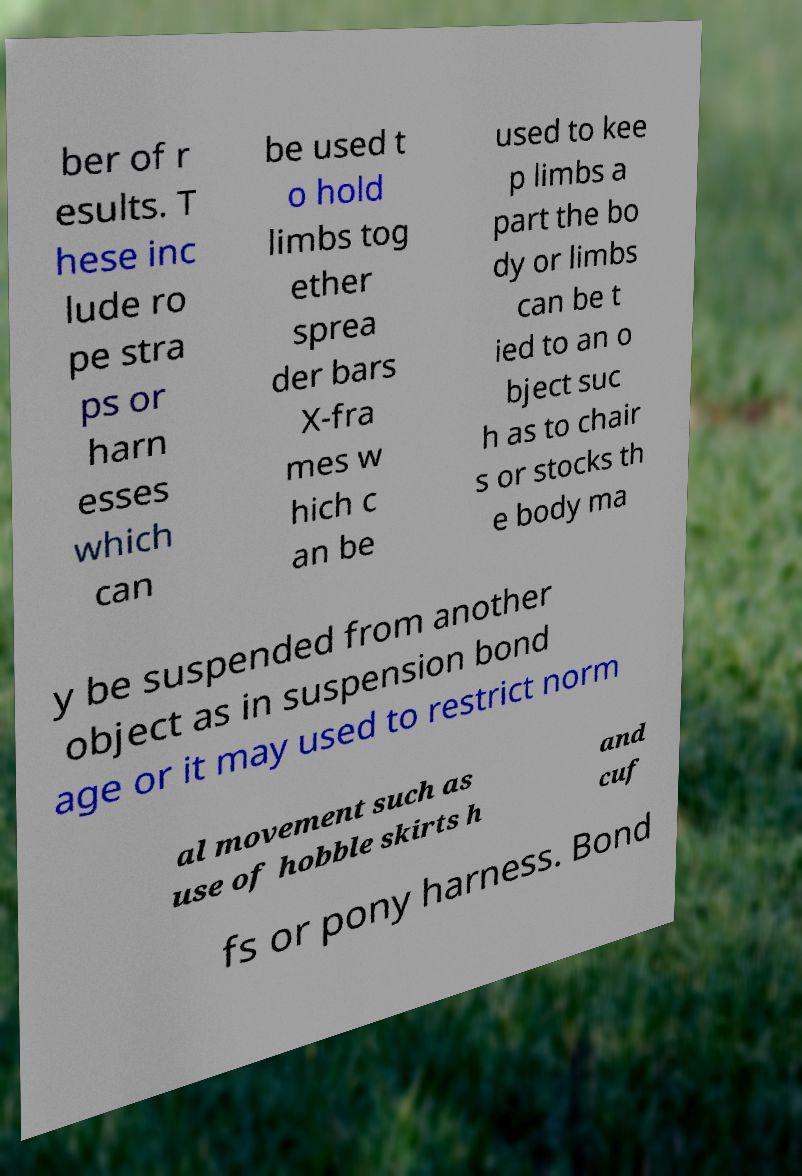For documentation purposes, I need the text within this image transcribed. Could you provide that? ber of r esults. T hese inc lude ro pe stra ps or harn esses which can be used t o hold limbs tog ether sprea der bars X-fra mes w hich c an be used to kee p limbs a part the bo dy or limbs can be t ied to an o bject suc h as to chair s or stocks th e body ma y be suspended from another object as in suspension bond age or it may used to restrict norm al movement such as use of hobble skirts h and cuf fs or pony harness. Bond 